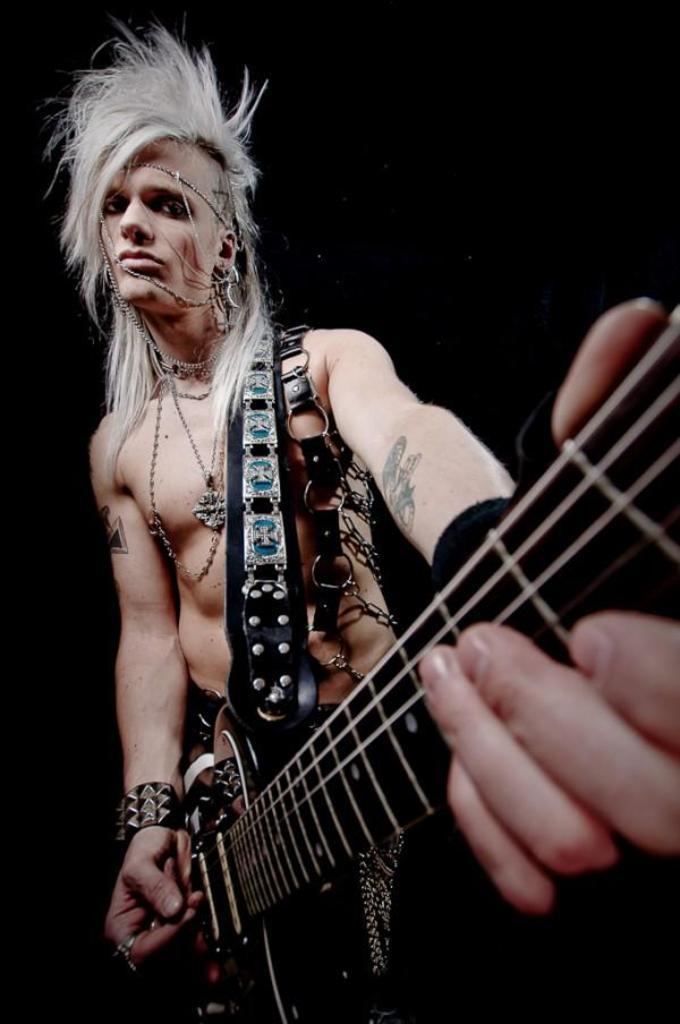Please provide a concise description of this image. In this picture a guy who is playing a guitar and is wearing a beautiful objects and also has a funky hairstyle. The background is black in color. 